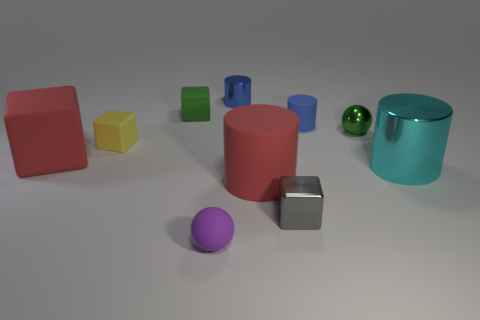There is a small object that is both on the right side of the tiny metallic block and behind the green shiny object; what material is it?
Offer a terse response. Rubber. Is there anything else that is the same size as the gray thing?
Keep it short and to the point. Yes. Is the color of the tiny matte sphere the same as the big metallic thing?
Make the answer very short. No. What shape is the tiny object that is the same color as the shiny ball?
Your answer should be compact. Cube. What number of small green shiny objects are the same shape as the blue matte object?
Offer a terse response. 0. What is the size of the blue cylinder that is the same material as the red block?
Ensure brevity in your answer.  Small. Is the red rubber cylinder the same size as the blue metal cylinder?
Give a very brief answer. No. Is there a big cyan metallic object?
Make the answer very short. Yes. The metallic cylinder that is the same color as the tiny rubber cylinder is what size?
Give a very brief answer. Small. There is a blue thing to the right of the blue shiny thing that is behind the block in front of the red block; how big is it?
Make the answer very short. Small. 